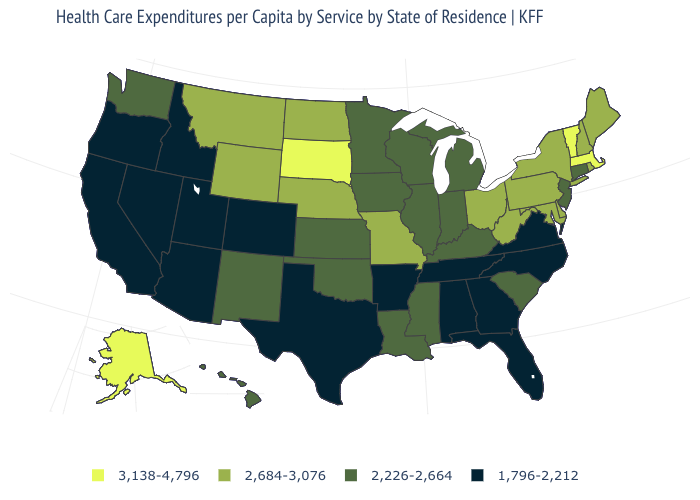What is the value of Nebraska?
Give a very brief answer. 2,684-3,076. What is the value of Colorado?
Quick response, please. 1,796-2,212. What is the value of North Carolina?
Short answer required. 1,796-2,212. What is the highest value in states that border Virginia?
Concise answer only. 2,684-3,076. What is the lowest value in the USA?
Answer briefly. 1,796-2,212. What is the lowest value in states that border Indiana?
Concise answer only. 2,226-2,664. Name the states that have a value in the range 2,226-2,664?
Write a very short answer. Connecticut, Hawaii, Illinois, Indiana, Iowa, Kansas, Kentucky, Louisiana, Michigan, Minnesota, Mississippi, New Jersey, New Mexico, Oklahoma, South Carolina, Washington, Wisconsin. Does the map have missing data?
Short answer required. No. Among the states that border Indiana , which have the highest value?
Quick response, please. Ohio. Name the states that have a value in the range 2,684-3,076?
Give a very brief answer. Delaware, Maine, Maryland, Missouri, Montana, Nebraska, New Hampshire, New York, North Dakota, Ohio, Pennsylvania, Rhode Island, West Virginia, Wyoming. Does Arkansas have the highest value in the South?
Concise answer only. No. What is the lowest value in the USA?
Quick response, please. 1,796-2,212. Which states have the lowest value in the MidWest?
Give a very brief answer. Illinois, Indiana, Iowa, Kansas, Michigan, Minnesota, Wisconsin. What is the value of Florida?
Concise answer only. 1,796-2,212. What is the highest value in states that border Louisiana?
Quick response, please. 2,226-2,664. 